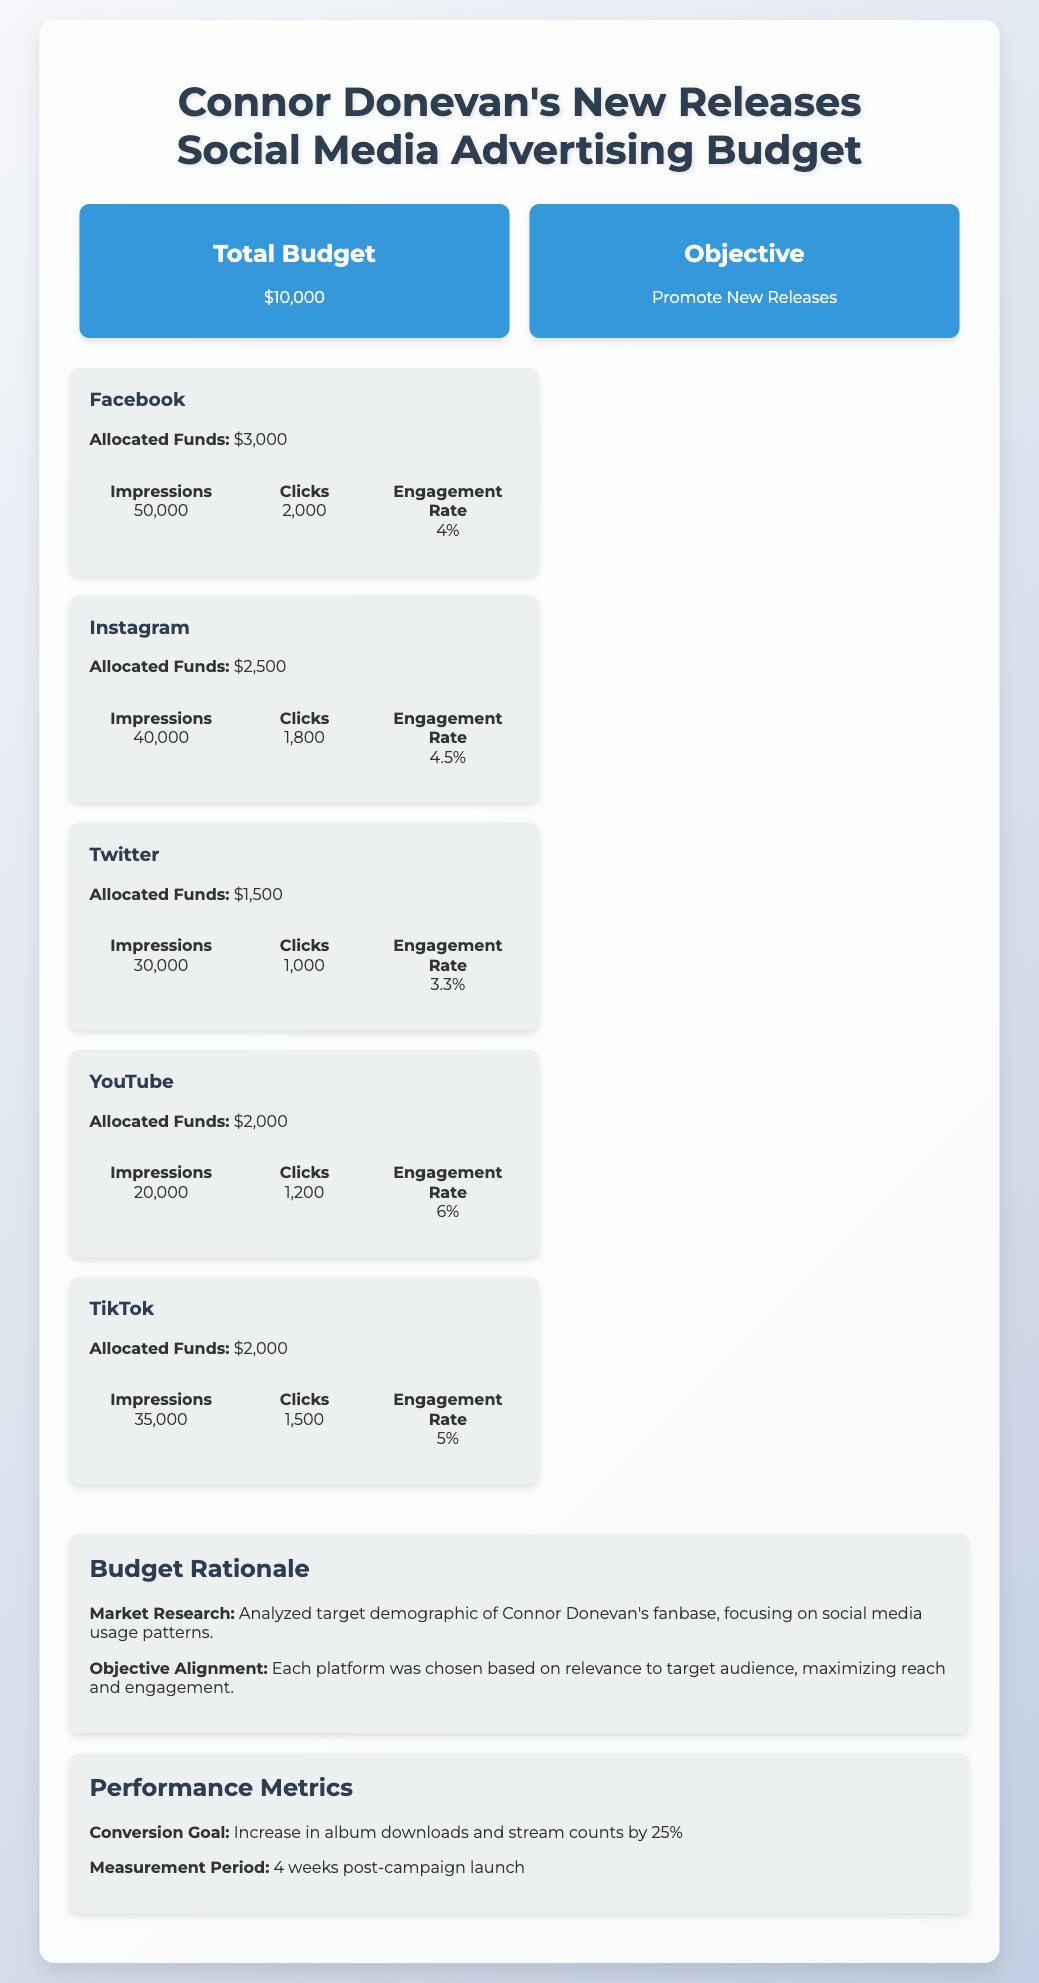what is the total budget? The total budget is stated in the document as $10,000.
Answer: $10,000 what platform has the highest allocated funds? The platform with the highest allocated funds is Facebook, which has $3,000 allocated.
Answer: Facebook what is the engagement rate for Instagram? The engagement rate for Instagram is provided as 4.5%.
Answer: 4.5% how many impressions are expected from Twitter? The number of impressions expected from Twitter is 30,000.
Answer: 30,000 what is the objective of the advertising budget? The objective is to promote new releases of Connor Donevan.
Answer: Promote New Releases which platform has the lowest engagement rate? The platform with the lowest engagement rate is Twitter, with 3.3%.
Answer: Twitter how much is allocated for YouTube? The allocated funds for YouTube are $2,000.
Answer: $2,000 what is the conversion goal mentioned in the document? The conversion goal is to increase album downloads and stream counts by 25%.
Answer: Increase by 25% how long is the measurement period for the campaign? The measurement period for the campaign is 4 weeks post-campaign launch.
Answer: 4 weeks 